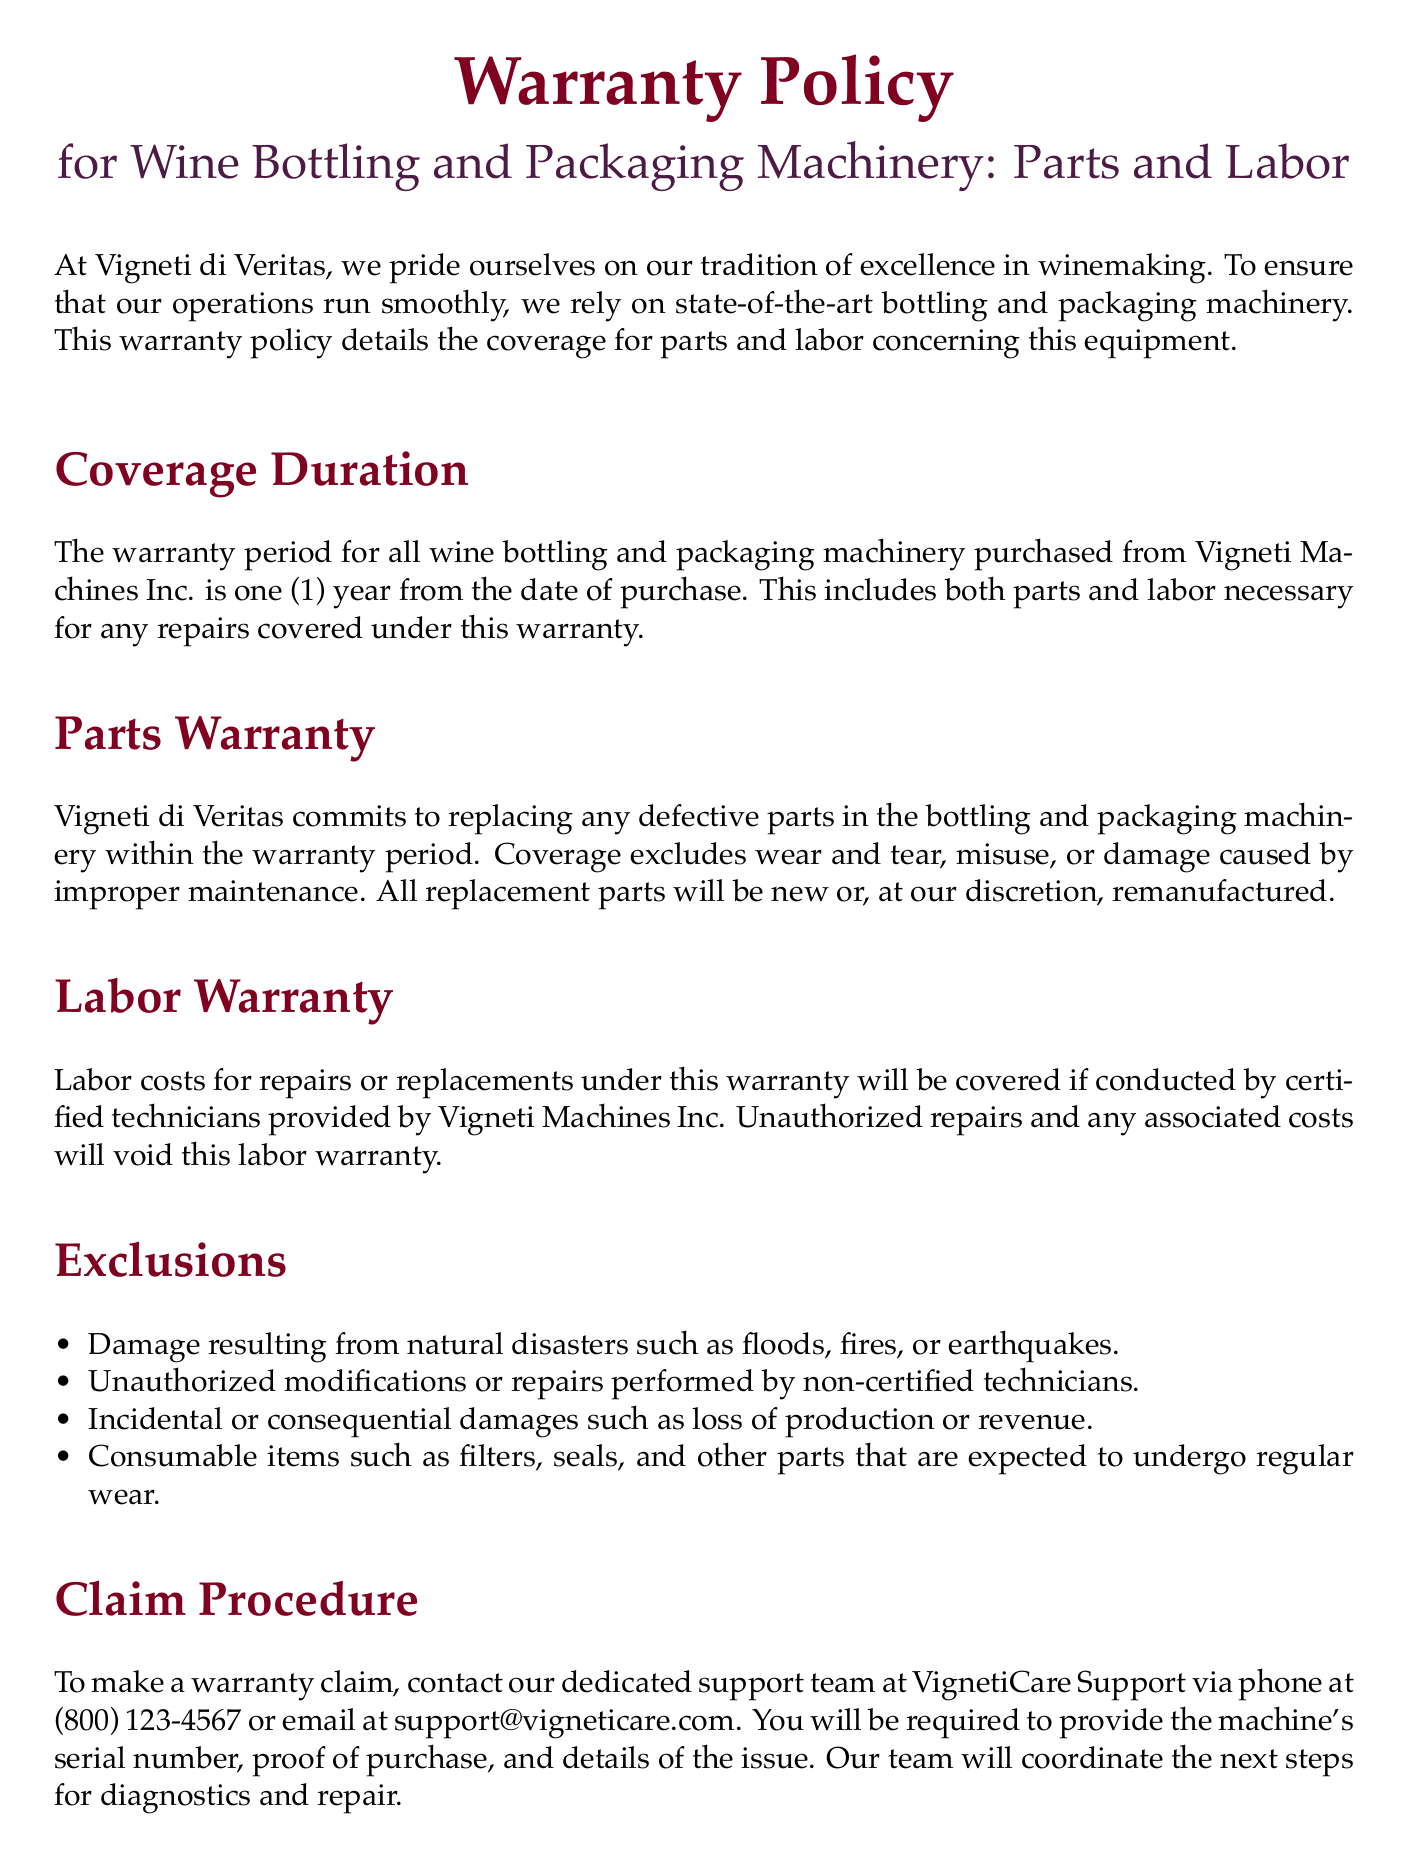What is the duration of the warranty? The warranty period for the machinery is specified in the document, which states that it lasts one (1) year from the date of purchase.
Answer: one (1) year What does the warranty cover? The document outlines that the warranty covers both parts and labor necessary for repairs within the warranty period.
Answer: parts and labor What is excluded from the Parts Warranty? The document lists exclusions from the parts warranty, including wear and tear, misuse, or damage from improper maintenance.
Answer: wear and tear, misuse, or damage from improper maintenance Who must conduct repairs to be covered by the labor warranty? The labor warranty specifies that repairs must be conducted by certified technicians to remain valid.
Answer: certified technicians What is the contact phone number for warranty claims? The document provides a specific contact phone number for making warranty claims, which is part of the claim procedure section.
Answer: (800) 123-4567 What kind of damages are excluded in the warranty? The document states that incidental or consequential damages such as loss of production or revenue are excluded from the warranty coverage.
Answer: loss of production or revenue What should a customer provide to make a warranty claim? The claim procedure section indicates that customers need to provide the machine's serial number, proof of purchase, and details of the issue.
Answer: serial number, proof of purchase, details of the issue What is the limitation of liability mentioned in the document? The document specifies that the liability under this warranty is limited to the repair or replacement of defective parts or machinery.
Answer: repair or replacement of defective parts or machinery Where is the warranty policy governed? The last part of the document mentions the governing law for this warranty policy.
Answer: the State of California 